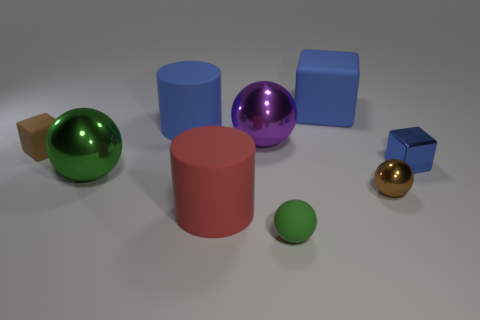Subtract all green balls. How many were subtracted if there are1green balls left? 1 Subtract all tiny brown metallic balls. How many balls are left? 3 Subtract all blocks. How many objects are left? 6 Add 1 big purple cubes. How many objects exist? 10 Subtract all gray cylinders. How many green spheres are left? 2 Subtract 0 yellow balls. How many objects are left? 9 Subtract 2 cubes. How many cubes are left? 1 Subtract all gray blocks. Subtract all green cylinders. How many blocks are left? 3 Subtract all big purple balls. Subtract all red matte objects. How many objects are left? 7 Add 5 brown balls. How many brown balls are left? 6 